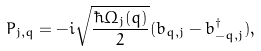<formula> <loc_0><loc_0><loc_500><loc_500>P _ { j , q } = - i \sqrt { \frac { \hbar { \Omega } _ { j } ( q ) } { 2 } } ( b _ { q , j } - b ^ { \dag } _ { - q , j } ) ,</formula> 